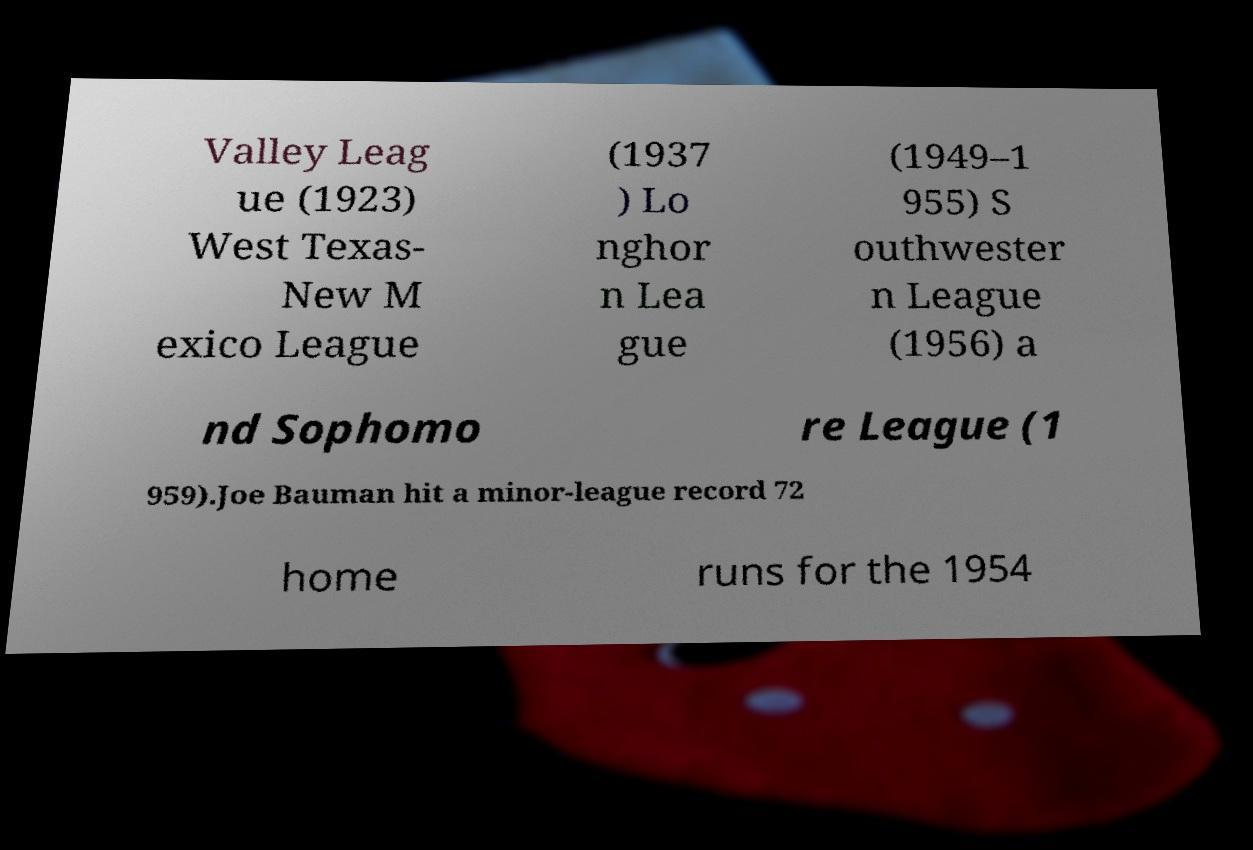What messages or text are displayed in this image? I need them in a readable, typed format. Valley Leag ue (1923) West Texas- New M exico League (1937 ) Lo nghor n Lea gue (1949–1 955) S outhwester n League (1956) a nd Sophomo re League (1 959).Joe Bauman hit a minor-league record 72 home runs for the 1954 